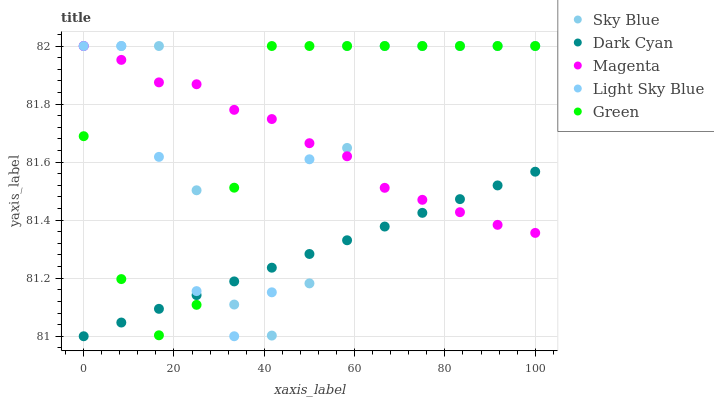Does Dark Cyan have the minimum area under the curve?
Answer yes or no. Yes. Does Green have the maximum area under the curve?
Answer yes or no. Yes. Does Sky Blue have the minimum area under the curve?
Answer yes or no. No. Does Sky Blue have the maximum area under the curve?
Answer yes or no. No. Is Dark Cyan the smoothest?
Answer yes or no. Yes. Is Sky Blue the roughest?
Answer yes or no. Yes. Is Magenta the smoothest?
Answer yes or no. No. Is Magenta the roughest?
Answer yes or no. No. Does Dark Cyan have the lowest value?
Answer yes or no. Yes. Does Sky Blue have the lowest value?
Answer yes or no. No. Does Green have the highest value?
Answer yes or no. Yes. Does Green intersect Light Sky Blue?
Answer yes or no. Yes. Is Green less than Light Sky Blue?
Answer yes or no. No. Is Green greater than Light Sky Blue?
Answer yes or no. No. 